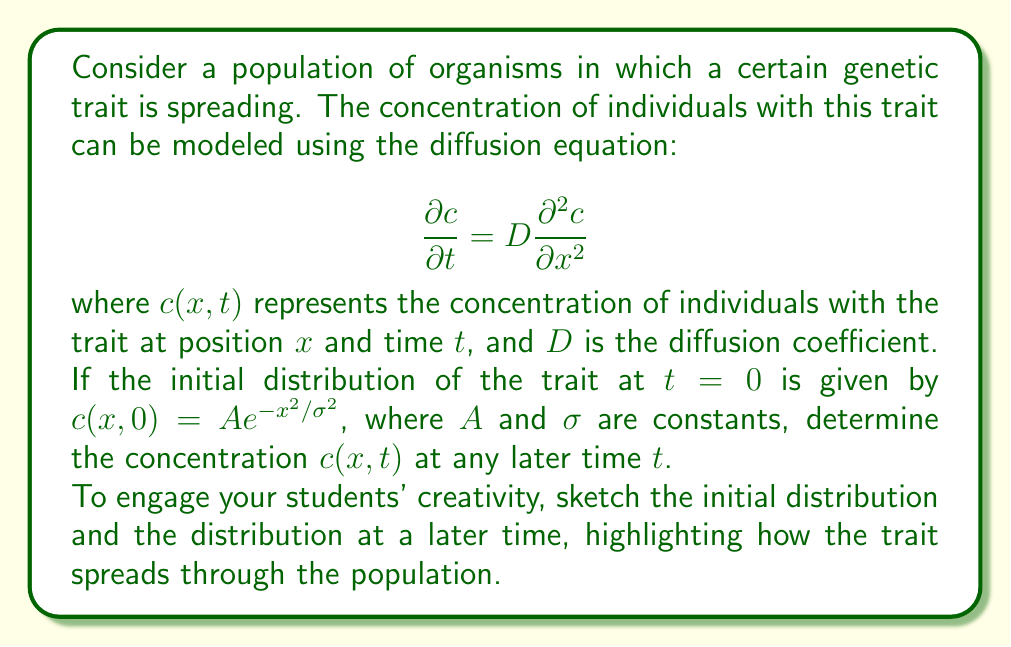Can you answer this question? Let's solve this problem step-by-step:

1) The given diffusion equation is:
   $$\frac{\partial c}{\partial t} = D \frac{\partial^2 c}{\partial x^2}$$

2) The initial condition is:
   $$c(x,0) = A e^{-x^2/\sigma^2}$$

3) To solve this, we can use the fundamental solution of the diffusion equation, which is:
   $$c(x,t) = \frac{1}{\sqrt{4\pi Dt}} \int_{-\infty}^{\infty} c(y,0) e^{-(x-y)^2/(4Dt)} dy$$

4) Substituting our initial condition:
   $$c(x,t) = \frac{A}{\sqrt{4\pi Dt}} \int_{-\infty}^{\infty} e^{-y^2/\sigma^2} e^{-(x-y)^2/(4Dt)} dy$$

5) This integral can be evaluated using the convolution of Gaussians formula:
   $$\int_{-\infty}^{\infty} e^{-ay^2} e^{-b(x-y)^2} dy = \sqrt{\frac{\pi}{a+b}} e^{-\frac{abx^2}{a+b}}$$

6) In our case, $a = 1/\sigma^2$ and $b = 1/(4Dt)$. Substituting these:
   $$c(x,t) = \frac{A}{\sqrt{4\pi Dt}} \sqrt{\frac{\pi}{\frac{1}{\sigma^2} + \frac{1}{4Dt}}} e^{-\frac{\frac{1}{\sigma^2}\frac{1}{4Dt}x^2}{\frac{1}{\sigma^2} + \frac{1}{4Dt}}}$$

7) Simplifying:
   $$c(x,t) = \frac{A\sigma}{\sqrt{\sigma^2 + 4Dt}} e^{-\frac{x^2}{\sigma^2 + 4Dt}}$$

This is the final solution for the concentration at any position $x$ and time $t$.

To visualize this, students can sketch the initial Gaussian distribution at $t=0$ and then show how it spreads out and decreases in height over time, illustrating the diffusion of the genetic trait through the population.
Answer: $$c(x,t) = \frac{A\sigma}{\sqrt{\sigma^2 + 4Dt}} e^{-\frac{x^2}{\sigma^2 + 4Dt}}$$ 